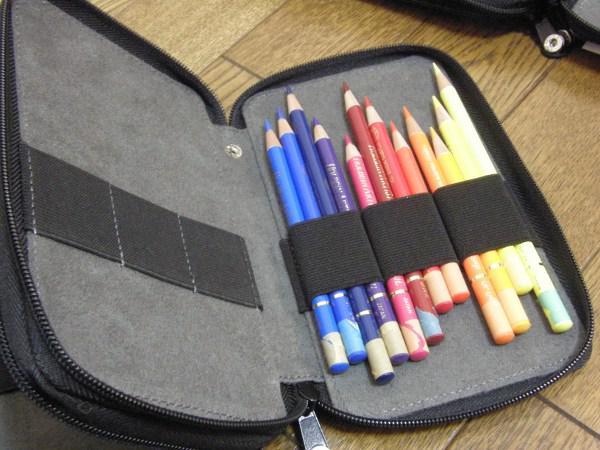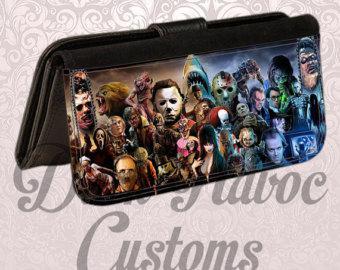The first image is the image on the left, the second image is the image on the right. Given the left and right images, does the statement "At least one image features a pencil holder made of jean denim, and an image shows a pencil holder atop a stack of paper items." hold true? Answer yes or no. No. 